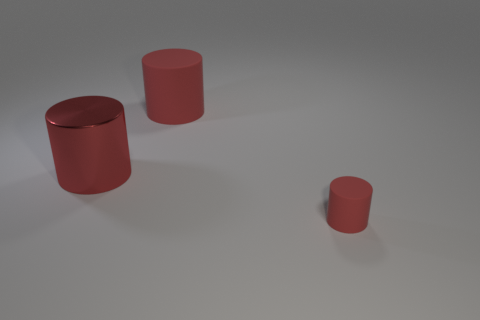Subtract all tiny rubber cylinders. How many cylinders are left? 2 Add 1 small cyan metal blocks. How many objects exist? 4 Subtract 0 gray cylinders. How many objects are left? 3 Subtract 3 cylinders. How many cylinders are left? 0 Subtract all yellow cylinders. Subtract all brown balls. How many cylinders are left? 3 Subtract all gray shiny things. Subtract all large red matte cylinders. How many objects are left? 2 Add 3 red rubber cylinders. How many red rubber cylinders are left? 5 Add 1 matte things. How many matte things exist? 3 